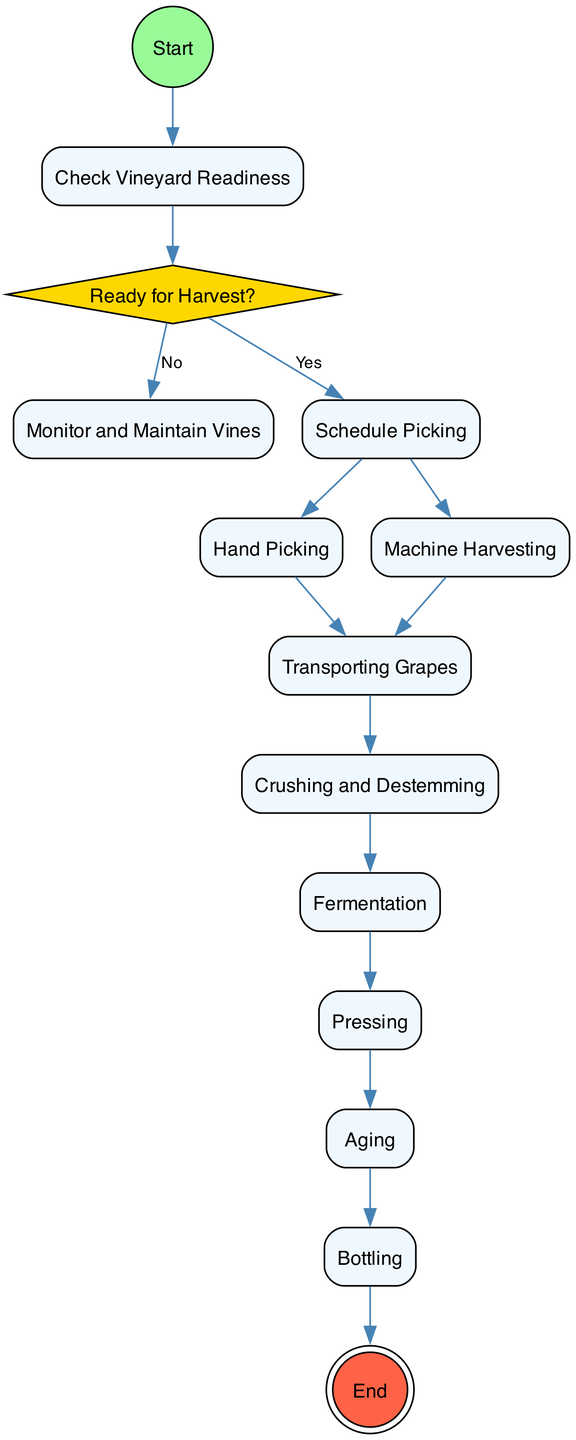What is the first action in the diagram? The diagram begins with the "Start", which is the initial node of the activity. Hence, the first action is the starting point of the entire process.
Answer: Start How many decision nodes are present in the diagram? There is a "Ready for Harvest?" node that serves as a decision point to determine if the vineyard is ready, making a total of one decision node in the diagram.
Answer: 1 What activity follows "Transporting Grapes"? After "Transporting Grapes," the next action in the sequence is "Crushing and Destemming," making it the activity that follows in the process.
Answer: Crushing and Destemming If the vineyard is not ready for harvest, what action is taken next? If the answer to "Ready for Harvest?" is "No," the next action taken is "Monitor and Maintain Vines." This is the specified alternative outcome based on the decision made.
Answer: Monitor and Maintain Vines What is the final activity in the grape processing sequence? The last activity before reaching the final node (End) is "Bottling," which signifies the completion of the wine preparation process and leads to the end of the activity.
Answer: Bottling Explain the transition from "Crushing and Destemming" to the next activity. After the "Crushing and Destemming" activity is complete, it transitions to "Fermentation," which is the step where the crushed grapes are fermented to produce wine, indicating a progression in the winemaking process.
Answer: Fermentation What happens if the decision node "Ready for Harvest?" leads to "Yes"? If "Ready for Harvest?" leads to "Yes," the process will move on to "Schedule Picking," which indicates that harvesting can commence, setting the stage for the grape collection activities.
Answer: Schedule Picking How many actions are there in the grape harvesting process? The diagram includes several action nodes in the process: "Check Vineyard Readiness," "Schedule Picking," "Hand Picking," "Machine Harvesting," "Transporting Grapes," "Crushing and Destemming," "Fermentation," "Pressing," "Aging," and "Bottling," totaling ten distinct actions.
Answer: 10 